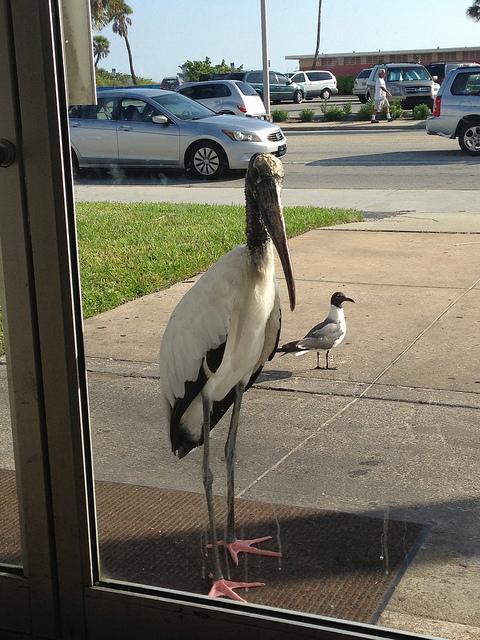Is there a beak on this animal?
Be succinct. Yes. What type of animal is this?
Quick response, please. Bird. How many cars are in the picture?
Answer briefly. 7. How many birds are in the picture?
Concise answer only. 2. 